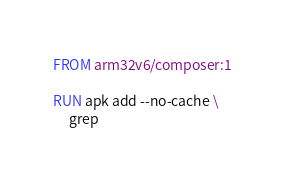Convert code to text. <code><loc_0><loc_0><loc_500><loc_500><_Dockerfile_>FROM arm32v6/composer:1

RUN apk add --no-cache \
     grep
</code> 